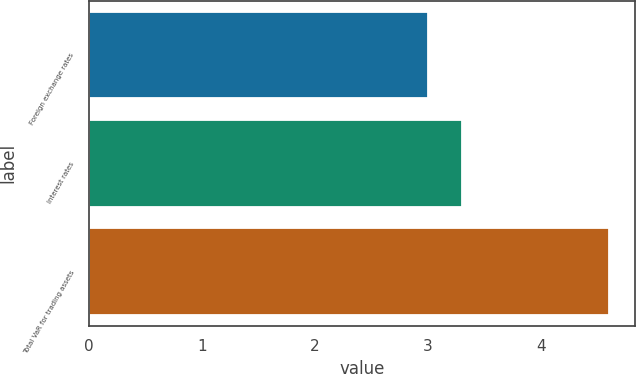Convert chart to OTSL. <chart><loc_0><loc_0><loc_500><loc_500><bar_chart><fcel>Foreign exchange rates<fcel>Interest rates<fcel>Total VaR for trading assets<nl><fcel>3<fcel>3.3<fcel>4.6<nl></chart> 